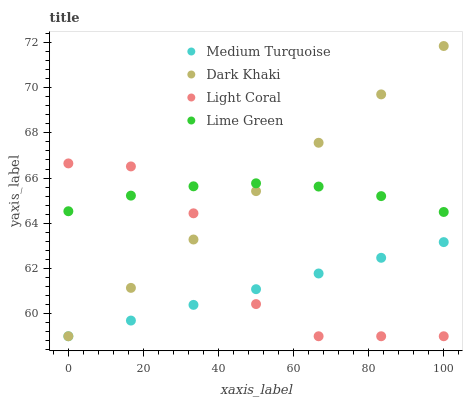Does Medium Turquoise have the minimum area under the curve?
Answer yes or no. Yes. Does Dark Khaki have the maximum area under the curve?
Answer yes or no. Yes. Does Light Coral have the minimum area under the curve?
Answer yes or no. No. Does Light Coral have the maximum area under the curve?
Answer yes or no. No. Is Dark Khaki the smoothest?
Answer yes or no. Yes. Is Light Coral the roughest?
Answer yes or no. Yes. Is Lime Green the smoothest?
Answer yes or no. No. Is Lime Green the roughest?
Answer yes or no. No. Does Dark Khaki have the lowest value?
Answer yes or no. Yes. Does Lime Green have the lowest value?
Answer yes or no. No. Does Dark Khaki have the highest value?
Answer yes or no. Yes. Does Light Coral have the highest value?
Answer yes or no. No. Is Medium Turquoise less than Lime Green?
Answer yes or no. Yes. Is Lime Green greater than Medium Turquoise?
Answer yes or no. Yes. Does Lime Green intersect Dark Khaki?
Answer yes or no. Yes. Is Lime Green less than Dark Khaki?
Answer yes or no. No. Is Lime Green greater than Dark Khaki?
Answer yes or no. No. Does Medium Turquoise intersect Lime Green?
Answer yes or no. No. 